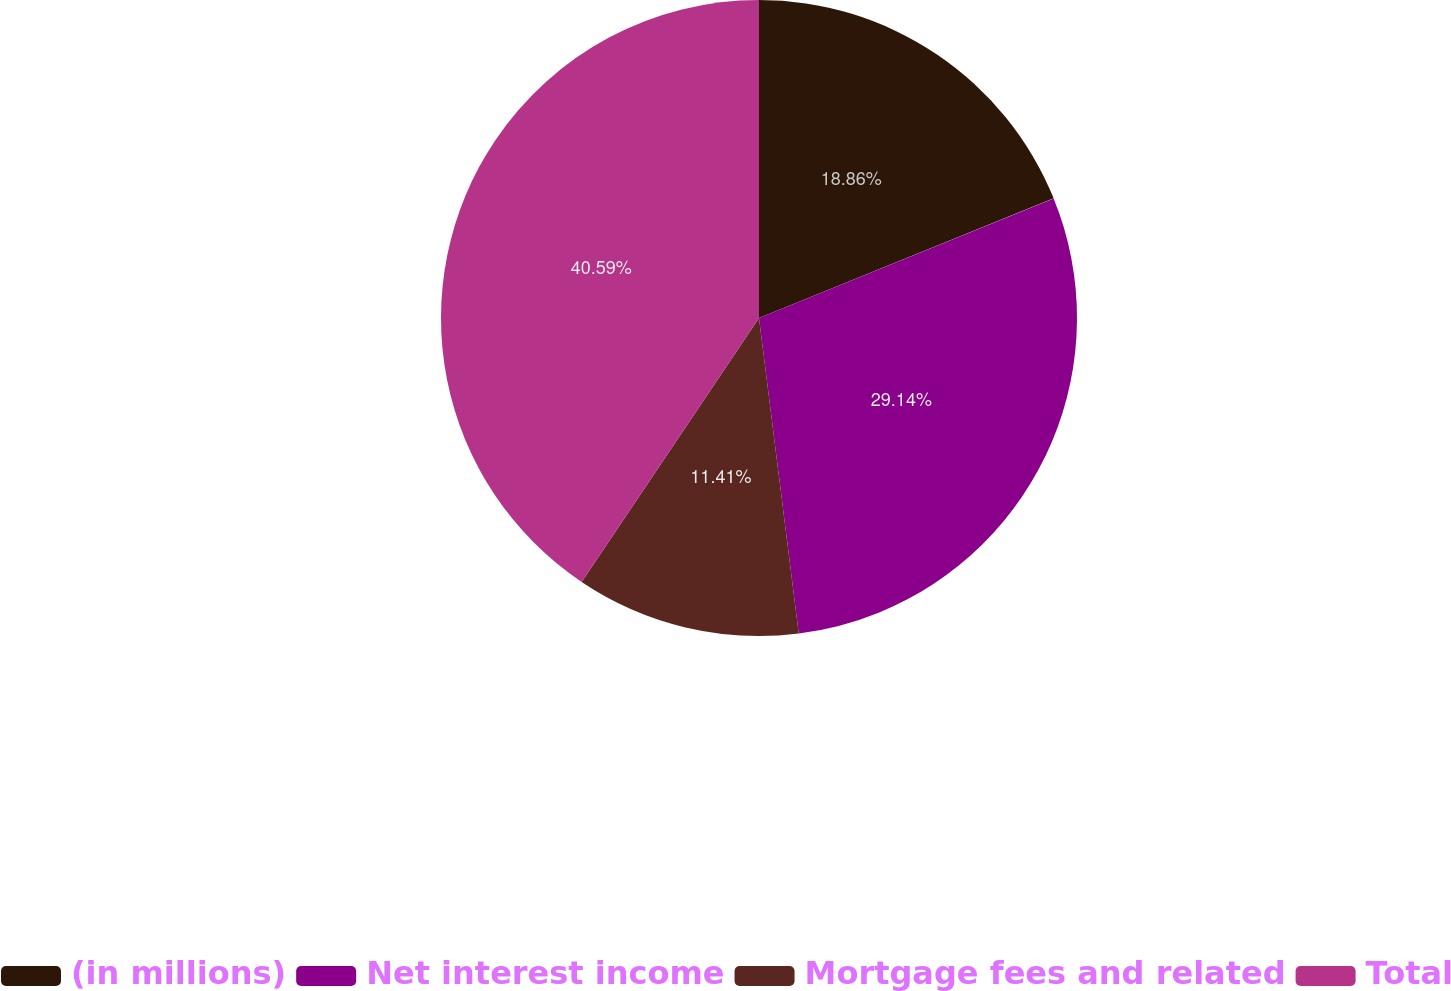Convert chart. <chart><loc_0><loc_0><loc_500><loc_500><pie_chart><fcel>(in millions)<fcel>Net interest income<fcel>Mortgage fees and related<fcel>Total<nl><fcel>18.86%<fcel>29.14%<fcel>11.41%<fcel>40.58%<nl></chart> 